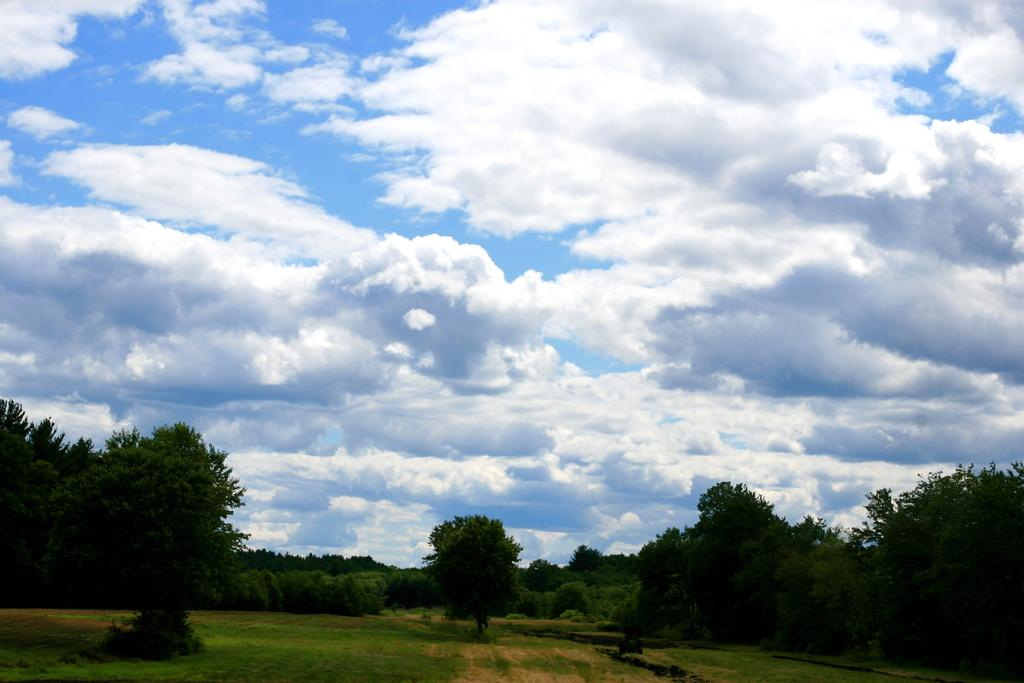What type of vegetation can be seen in the image? There are trees and grass in the image. What is visible in the background of the image? The sky is visible in the background of the image. What can be observed in the sky? Clouds are present in the sky. What is the distance between the father and the trees in the image? There is no father present in the image, so it is not possible to determine the distance between him and the trees. 